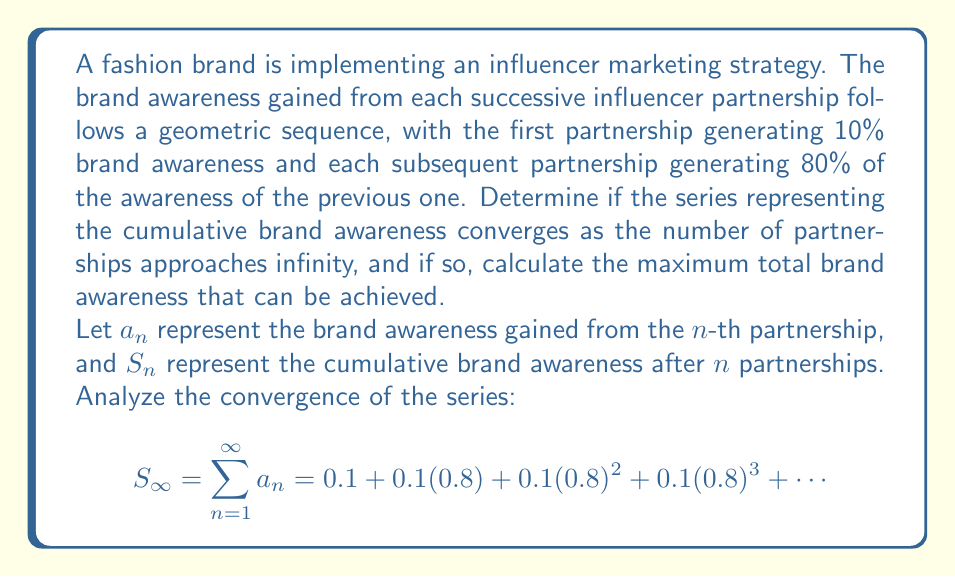Teach me how to tackle this problem. To analyze the convergence of this series, we'll follow these steps:

1) First, identify the series as a geometric series with first term $a = 0.1$ and common ratio $r = 0.8$.

2) For a geometric series $\sum_{n=1}^{\infty} ar^{n-1}$, it converges if and only if $|r| < 1$.

3) In this case, $r = 0.8$, and $|0.8| < 1$, so the series converges.

4) For a convergent geometric series, the sum to infinity is given by the formula:

   $$S_{\infty} = \frac{a}{1-r}$$

5) Substituting our values:

   $$S_{\infty} = \frac{0.1}{1-0.8} = \frac{0.1}{0.2} = 0.5$$

6) Therefore, the series converges to 0.5, or 50% brand awareness.

This means that as the brand continues to partner with more and more influencers, the cumulative brand awareness will approach, but never exceed, 50%. Each new partnership will add to the total awareness, but in diminishing amounts, creating an asymptotic approach to 50%.
Answer: The series converges. The maximum total brand awareness that can be achieved is 50%. 